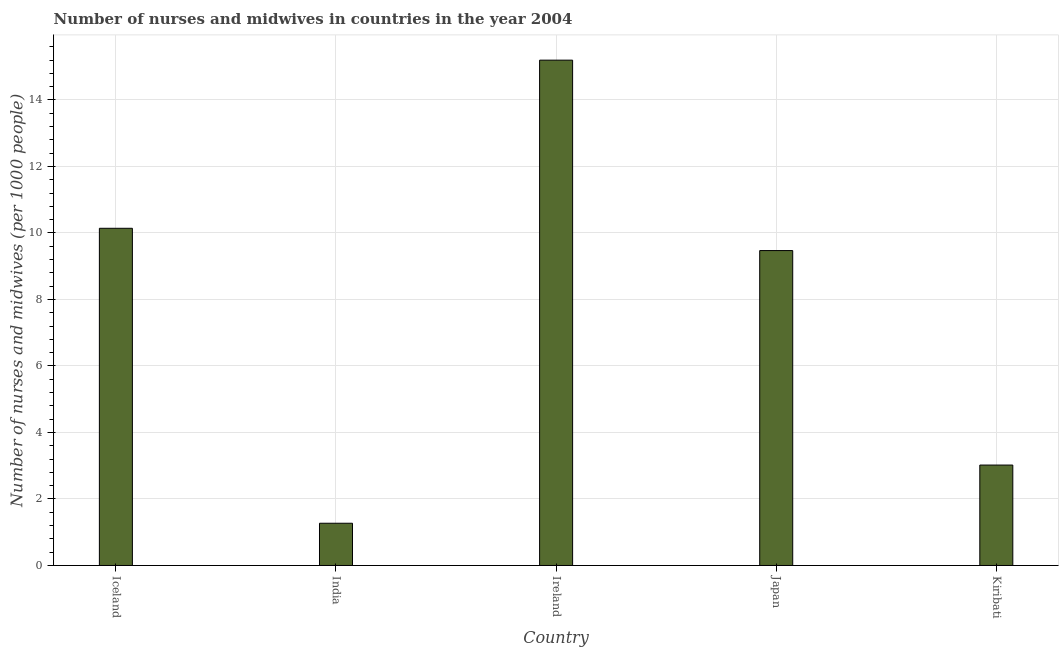What is the title of the graph?
Offer a very short reply. Number of nurses and midwives in countries in the year 2004. What is the label or title of the X-axis?
Your answer should be compact. Country. What is the label or title of the Y-axis?
Your response must be concise. Number of nurses and midwives (per 1000 people). What is the number of nurses and midwives in India?
Offer a very short reply. 1.27. Across all countries, what is the maximum number of nurses and midwives?
Offer a terse response. 15.2. Across all countries, what is the minimum number of nurses and midwives?
Your answer should be very brief. 1.27. In which country was the number of nurses and midwives maximum?
Your answer should be very brief. Ireland. In which country was the number of nurses and midwives minimum?
Provide a succinct answer. India. What is the sum of the number of nurses and midwives?
Provide a short and direct response. 39.1. What is the average number of nurses and midwives per country?
Make the answer very short. 7.82. What is the median number of nurses and midwives?
Your response must be concise. 9.47. In how many countries, is the number of nurses and midwives greater than 13.6 ?
Your response must be concise. 1. What is the ratio of the number of nurses and midwives in India to that in Kiribati?
Your answer should be compact. 0.42. What is the difference between the highest and the second highest number of nurses and midwives?
Your answer should be very brief. 5.06. What is the difference between the highest and the lowest number of nurses and midwives?
Provide a short and direct response. 13.93. In how many countries, is the number of nurses and midwives greater than the average number of nurses and midwives taken over all countries?
Provide a short and direct response. 3. What is the difference between two consecutive major ticks on the Y-axis?
Your answer should be compact. 2. What is the Number of nurses and midwives (per 1000 people) in Iceland?
Your response must be concise. 10.14. What is the Number of nurses and midwives (per 1000 people) in India?
Offer a terse response. 1.27. What is the Number of nurses and midwives (per 1000 people) in Ireland?
Give a very brief answer. 15.2. What is the Number of nurses and midwives (per 1000 people) in Japan?
Keep it short and to the point. 9.47. What is the Number of nurses and midwives (per 1000 people) in Kiribati?
Ensure brevity in your answer.  3.02. What is the difference between the Number of nurses and midwives (per 1000 people) in Iceland and India?
Give a very brief answer. 8.87. What is the difference between the Number of nurses and midwives (per 1000 people) in Iceland and Ireland?
Your answer should be very brief. -5.06. What is the difference between the Number of nurses and midwives (per 1000 people) in Iceland and Japan?
Your answer should be compact. 0.67. What is the difference between the Number of nurses and midwives (per 1000 people) in Iceland and Kiribati?
Your response must be concise. 7.12. What is the difference between the Number of nurses and midwives (per 1000 people) in India and Ireland?
Your answer should be very brief. -13.93. What is the difference between the Number of nurses and midwives (per 1000 people) in India and Japan?
Offer a very short reply. -8.2. What is the difference between the Number of nurses and midwives (per 1000 people) in India and Kiribati?
Make the answer very short. -1.75. What is the difference between the Number of nurses and midwives (per 1000 people) in Ireland and Japan?
Provide a succinct answer. 5.73. What is the difference between the Number of nurses and midwives (per 1000 people) in Ireland and Kiribati?
Ensure brevity in your answer.  12.18. What is the difference between the Number of nurses and midwives (per 1000 people) in Japan and Kiribati?
Ensure brevity in your answer.  6.45. What is the ratio of the Number of nurses and midwives (per 1000 people) in Iceland to that in India?
Your answer should be very brief. 7.98. What is the ratio of the Number of nurses and midwives (per 1000 people) in Iceland to that in Ireland?
Provide a succinct answer. 0.67. What is the ratio of the Number of nurses and midwives (per 1000 people) in Iceland to that in Japan?
Offer a terse response. 1.07. What is the ratio of the Number of nurses and midwives (per 1000 people) in Iceland to that in Kiribati?
Your answer should be very brief. 3.36. What is the ratio of the Number of nurses and midwives (per 1000 people) in India to that in Ireland?
Your response must be concise. 0.08. What is the ratio of the Number of nurses and midwives (per 1000 people) in India to that in Japan?
Offer a very short reply. 0.13. What is the ratio of the Number of nurses and midwives (per 1000 people) in India to that in Kiribati?
Your answer should be compact. 0.42. What is the ratio of the Number of nurses and midwives (per 1000 people) in Ireland to that in Japan?
Keep it short and to the point. 1.6. What is the ratio of the Number of nurses and midwives (per 1000 people) in Ireland to that in Kiribati?
Your response must be concise. 5.03. What is the ratio of the Number of nurses and midwives (per 1000 people) in Japan to that in Kiribati?
Your answer should be very brief. 3.14. 